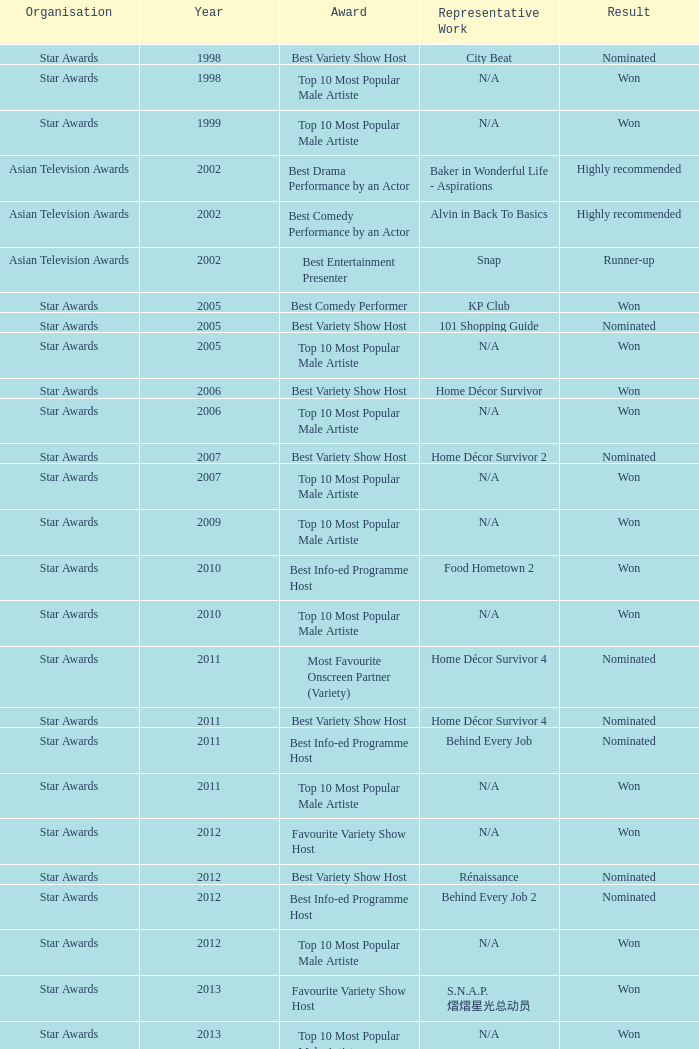What is the name of the Representative Work in a year later than 2005 with a Result of nominated, and an Award of best variety show host? Home Décor Survivor 2, Home Décor Survivor 4, Rénaissance, Jobs Around The World. Would you mind parsing the complete table? {'header': ['Organisation', 'Year', 'Award', 'Representative Work', 'Result'], 'rows': [['Star Awards', '1998', 'Best Variety Show Host', 'City Beat', 'Nominated'], ['Star Awards', '1998', 'Top 10 Most Popular Male Artiste', 'N/A', 'Won'], ['Star Awards', '1999', 'Top 10 Most Popular Male Artiste', 'N/A', 'Won'], ['Asian Television Awards', '2002', 'Best Drama Performance by an Actor', 'Baker in Wonderful Life - Aspirations', 'Highly recommended'], ['Asian Television Awards', '2002', 'Best Comedy Performance by an Actor', 'Alvin in Back To Basics', 'Highly recommended'], ['Asian Television Awards', '2002', 'Best Entertainment Presenter', 'Snap', 'Runner-up'], ['Star Awards', '2005', 'Best Comedy Performer', 'KP Club', 'Won'], ['Star Awards', '2005', 'Best Variety Show Host', '101 Shopping Guide', 'Nominated'], ['Star Awards', '2005', 'Top 10 Most Popular Male Artiste', 'N/A', 'Won'], ['Star Awards', '2006', 'Best Variety Show Host', 'Home Décor Survivor', 'Won'], ['Star Awards', '2006', 'Top 10 Most Popular Male Artiste', 'N/A', 'Won'], ['Star Awards', '2007', 'Best Variety Show Host', 'Home Décor Survivor 2', 'Nominated'], ['Star Awards', '2007', 'Top 10 Most Popular Male Artiste', 'N/A', 'Won'], ['Star Awards', '2009', 'Top 10 Most Popular Male Artiste', 'N/A', 'Won'], ['Star Awards', '2010', 'Best Info-ed Programme Host', 'Food Hometown 2', 'Won'], ['Star Awards', '2010', 'Top 10 Most Popular Male Artiste', 'N/A', 'Won'], ['Star Awards', '2011', 'Most Favourite Onscreen Partner (Variety)', 'Home Décor Survivor 4', 'Nominated'], ['Star Awards', '2011', 'Best Variety Show Host', 'Home Décor Survivor 4', 'Nominated'], ['Star Awards', '2011', 'Best Info-ed Programme Host', 'Behind Every Job', 'Nominated'], ['Star Awards', '2011', 'Top 10 Most Popular Male Artiste', 'N/A', 'Won'], ['Star Awards', '2012', 'Favourite Variety Show Host', 'N/A', 'Won'], ['Star Awards', '2012', 'Best Variety Show Host', 'Rénaissance', 'Nominated'], ['Star Awards', '2012', 'Best Info-ed Programme Host', 'Behind Every Job 2', 'Nominated'], ['Star Awards', '2012', 'Top 10 Most Popular Male Artiste', 'N/A', 'Won'], ['Star Awards', '2013', 'Favourite Variety Show Host', 'S.N.A.P. 熠熠星光总动员', 'Won'], ['Star Awards', '2013', 'Top 10 Most Popular Male Artiste', 'N/A', 'Won'], ['Star Awards', '2013', 'Best Info-Ed Programme Host', 'Makan Unlimited', 'Nominated'], ['Star Awards', '2013', 'Best Variety Show Host', 'Jobs Around The World', 'Nominated']]} 